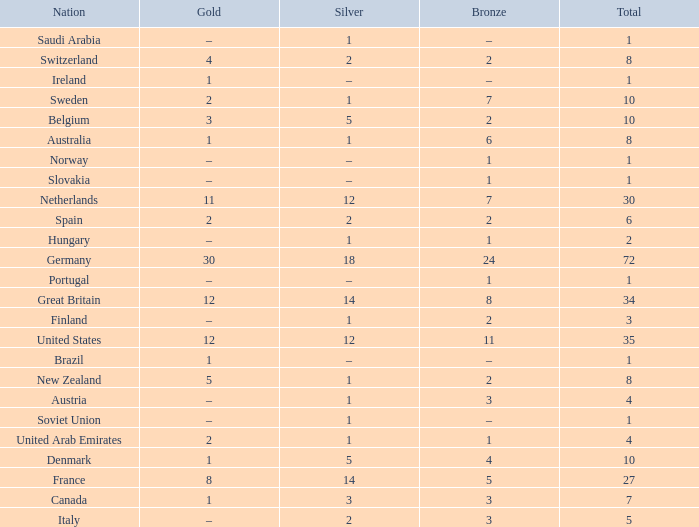What is the total number of Total, when Silver is 1, and when Bronze is 7? 1.0. 